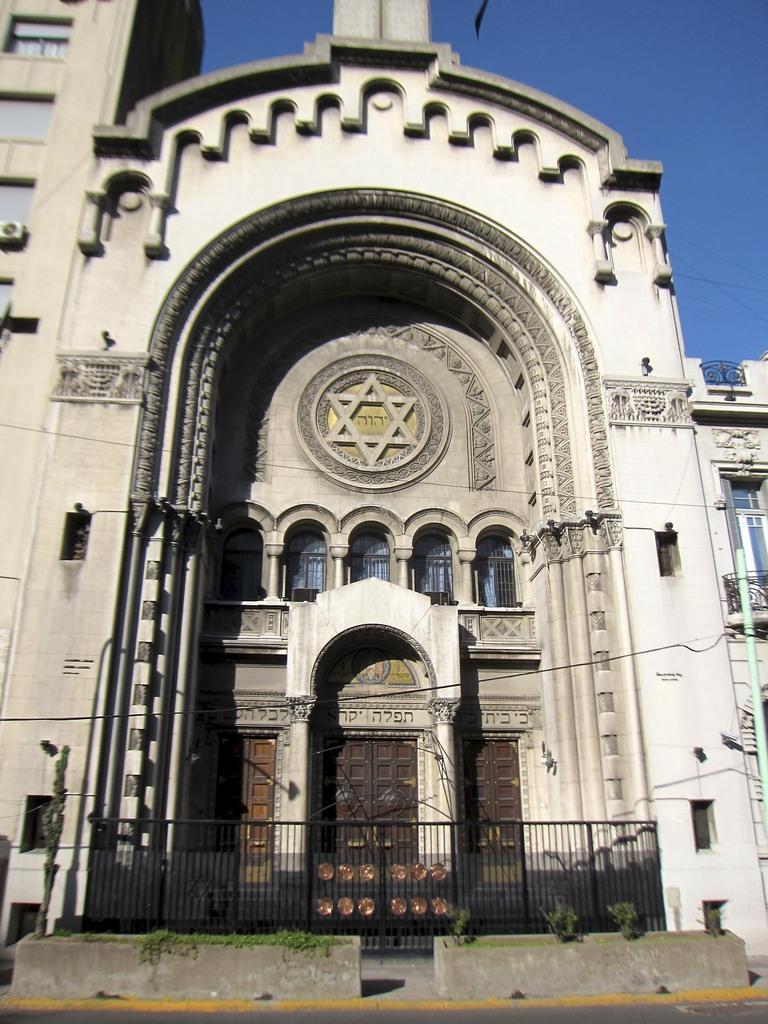Please provide a concise description of this image. In the foreground of this image, there is a railing and a building. At the top, there is the sky. 